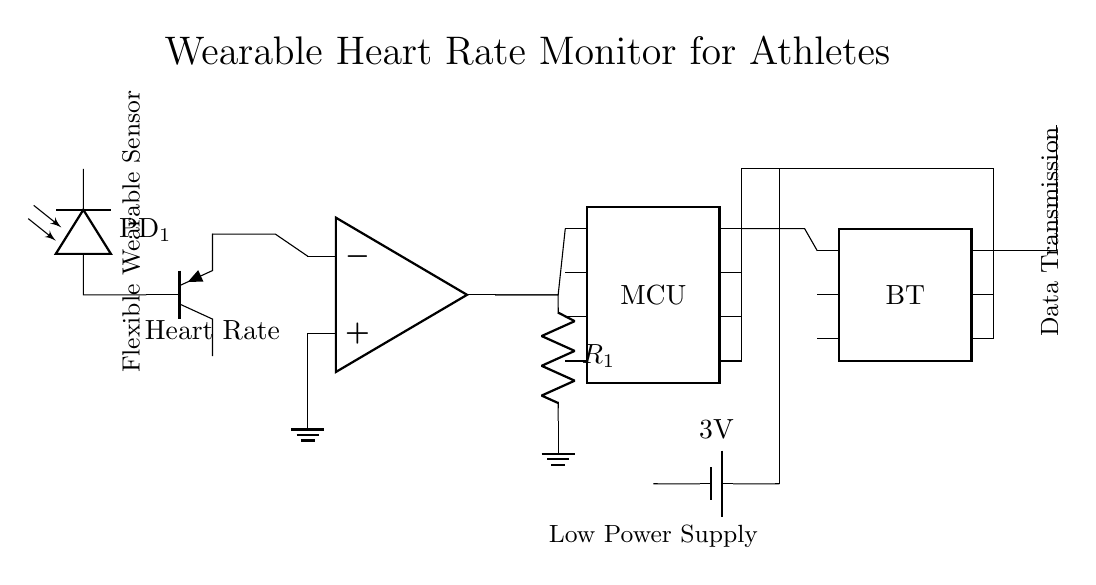What type of sensor is used in this circuit? The sensor labeled as "Heart Rate" indicates it is a heart rate sensor. The component is specifically identified as a photodiode that detects heart rate-related signals.
Answer: Heart Rate Sensor What is the function of the amplifier in this circuit? The amplifier, marked as "OA1," is used to increase the output signal from the heart rate sensor for better readability and further processing by other components.
Answer: Signal amplification What is the voltage provided by the battery? The circuit shows a battery labeled with "3V," which indicates the voltage it supplies to power the device.
Answer: 3V How is data transmitted in this device? Data transmission is facilitated by the Bluetooth module, identified in the circuit as "BT," which connects to the microcontroller for wireless communication.
Answer: Bluetooth What is the role of the antenna in this circuit? The antenna connects to the Bluetooth module and is responsible for transmitting the data wirelessly, allowing for communication between the device and other devices or applications.
Answer: Data transmission Which component connects the sensor to the microcontroller? The output line from the heart rate sensor leads directly to the input pin of the microcontroller, indicating that the microcontroller receives the processed signals from the sensor.
Answer: Microcontroller Why is low power design important for this circuit? Low power design is critical for wearable devices like this heart rate monitor to ensure they can operate for extended periods on small batteries without overheating, which is crucial for athlete convenience during training and competitions.
Answer: Power efficiency 